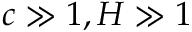<formula> <loc_0><loc_0><loc_500><loc_500>c \gg 1 , H \gg 1</formula> 